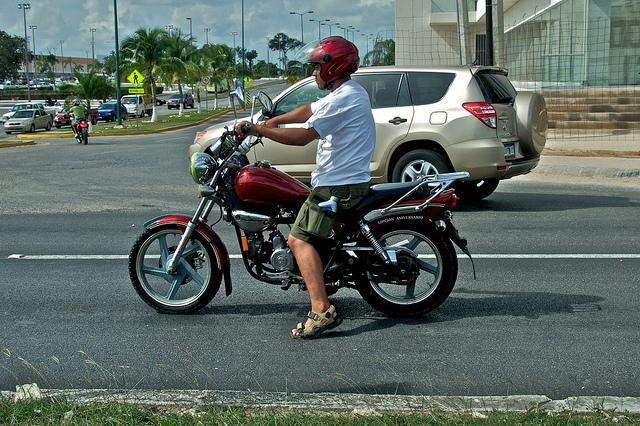Is the motorcycle rider wearing boots?
Be succinct. No. What color is the car behind the scooter?
Short answer required. Gold. What color is the biker's helmet?
Answer briefly. Red. What sign is in the background?
Be succinct. Walk. What color is the helmet?
Give a very brief answer. Red. How many cars are there?
Quick response, please. 6. Is the person in motion?
Quick response, please. No. Does the man's helmet match the motorcycles gas tank?
Quick response, please. Yes. 